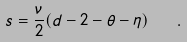Convert formula to latex. <formula><loc_0><loc_0><loc_500><loc_500>s = \frac { \nu } { 2 } ( d - 2 - \theta - \eta ) \quad .</formula> 